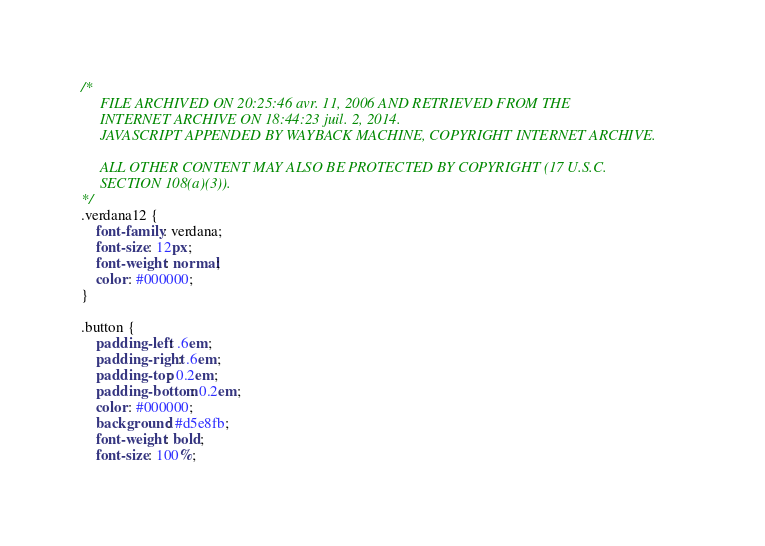Convert code to text. <code><loc_0><loc_0><loc_500><loc_500><_CSS_>




/*
     FILE ARCHIVED ON 20:25:46 avr. 11, 2006 AND RETRIEVED FROM THE
     INTERNET ARCHIVE ON 18:44:23 juil. 2, 2014.
     JAVASCRIPT APPENDED BY WAYBACK MACHINE, COPYRIGHT INTERNET ARCHIVE.

     ALL OTHER CONTENT MAY ALSO BE PROTECTED BY COPYRIGHT (17 U.S.C.
     SECTION 108(a)(3)).
*/
.verdana12 {
	font-family: verdana;
	font-size: 12px;
	font-weight: normal;
	color: #000000;
}

.button {
	padding-left: .6em;
	padding-right: .6em;
	padding-top: 0.2em;
	padding-bottom: 0.2em;
	color: #000000;
	background: #d5e8fb;
	font-weight: bold;
	font-size: 100%;</code> 